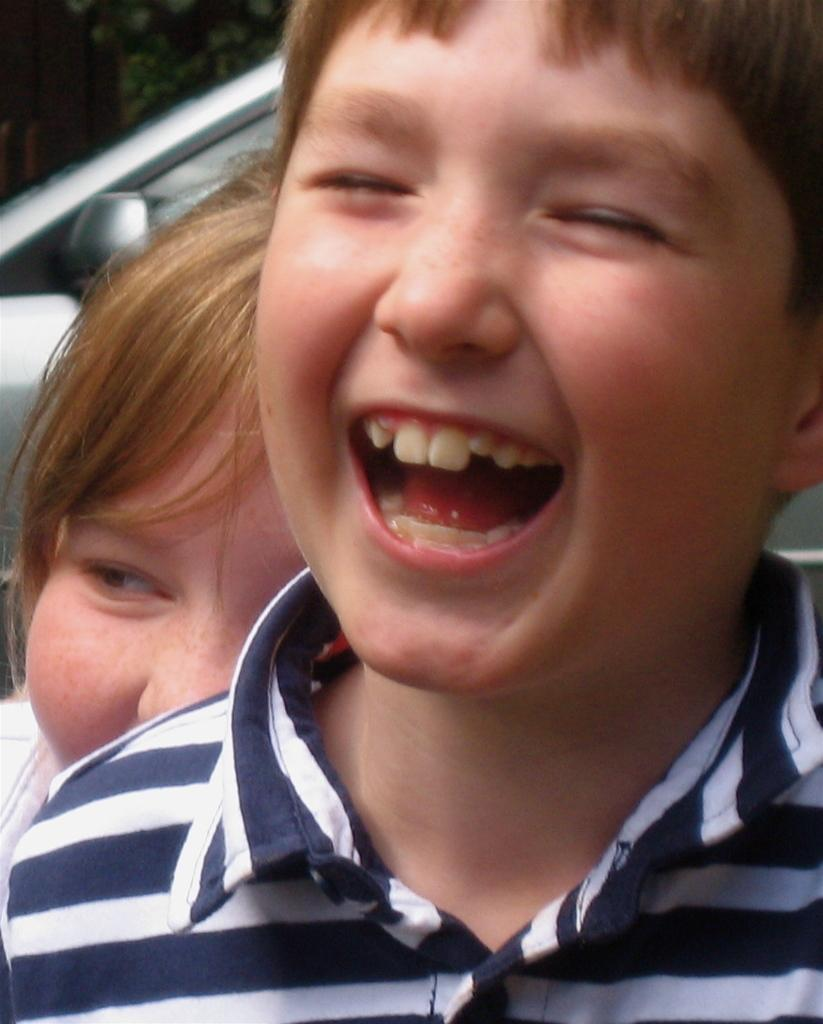What is the main subject in the foreground of the image? There is a boy in the foreground of the image. What is the boy in the foreground doing? The boy in the foreground is smiling. Can you describe the background of the image? There is another boy and objects in the background of the image. What type of detail can be seen on the boy's shirt in the image? There is no specific detail mentioned on the boy's shirt in the provided facts, so it cannot be determined from the image. 